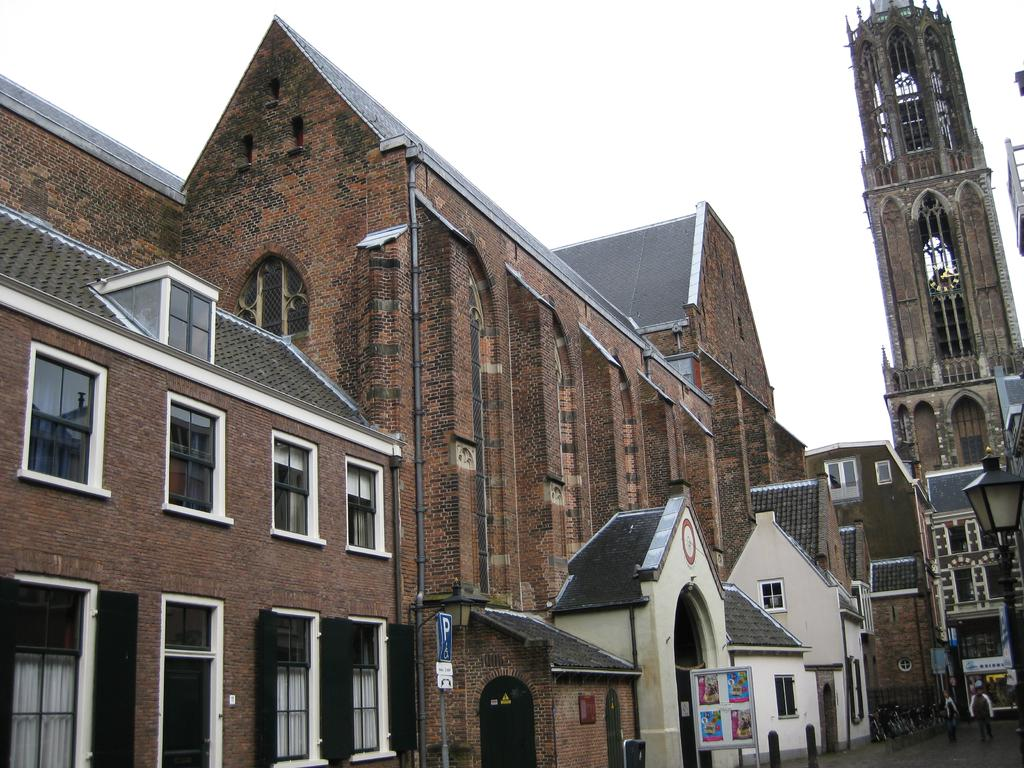What can be seen in the image? There are people, bicycles, name boards, an electric pole with a light, buildings, and metal poles in the image. What are the people doing in the image? The activity of the people cannot be determined from the provided facts. What is the purpose of the name boards in the image? The purpose of the name boards cannot be determined from the provided facts. What is attached to the electric pole in the image? A light is attached to the electric pole in the image. What is visible in the background of the image? The sky is visible in the background of the image. How many buckets are visible in the image? There are no buckets present in the image. What is the size of the jail in the image? There is no jail present in the image. 